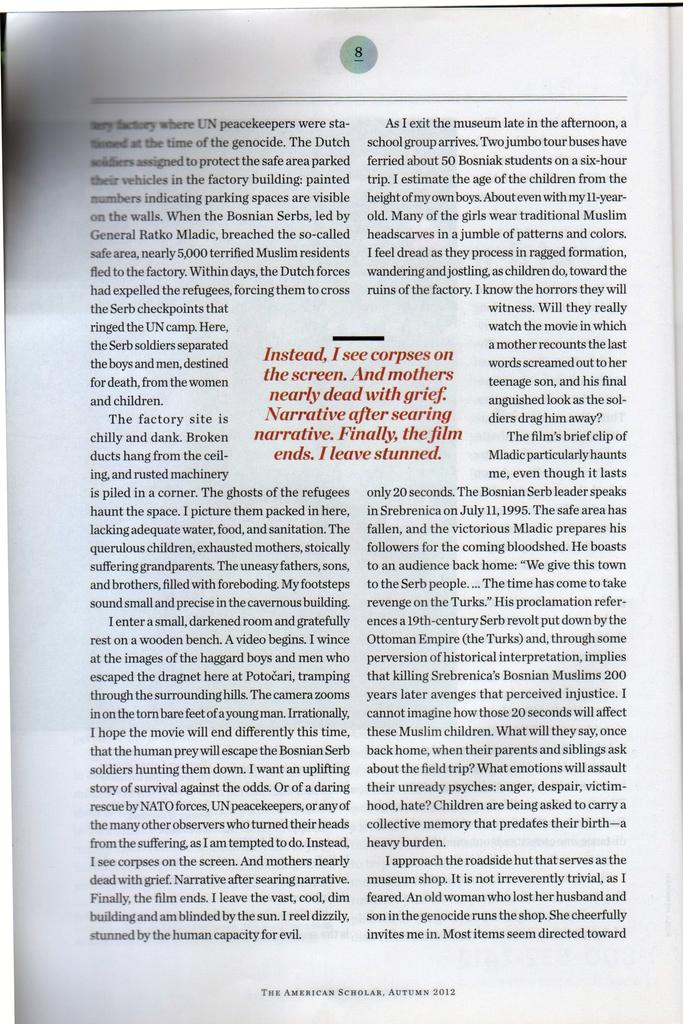Provide a one-sentence caption for the provided image. A book is lying open to page 8. 